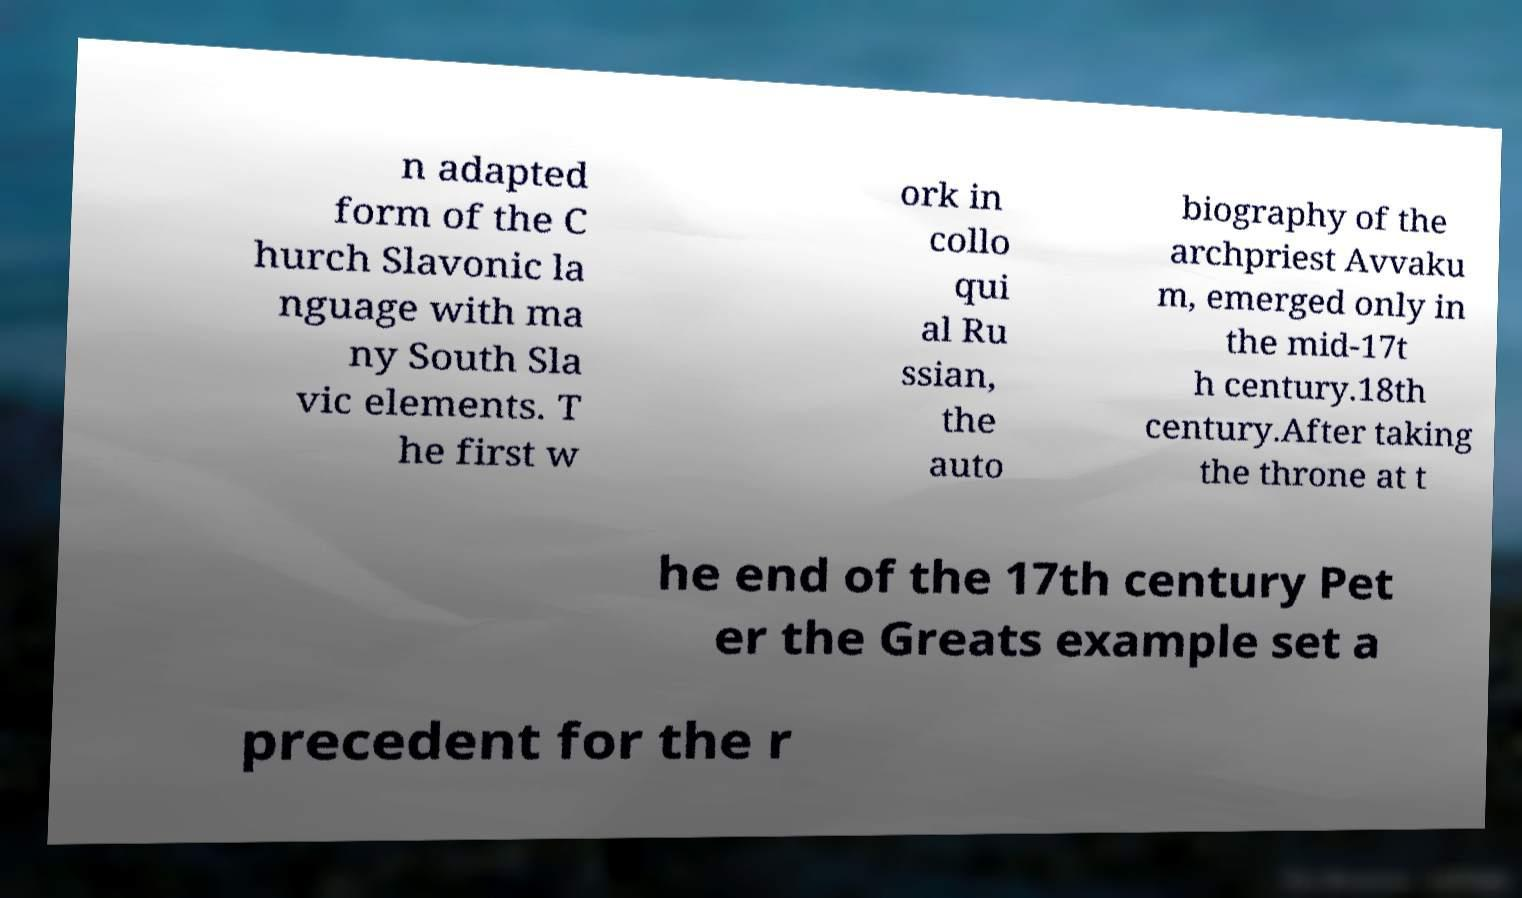For documentation purposes, I need the text within this image transcribed. Could you provide that? n adapted form of the C hurch Slavonic la nguage with ma ny South Sla vic elements. T he first w ork in collo qui al Ru ssian, the auto biography of the archpriest Avvaku m, emerged only in the mid-17t h century.18th century.After taking the throne at t he end of the 17th century Pet er the Greats example set a precedent for the r 